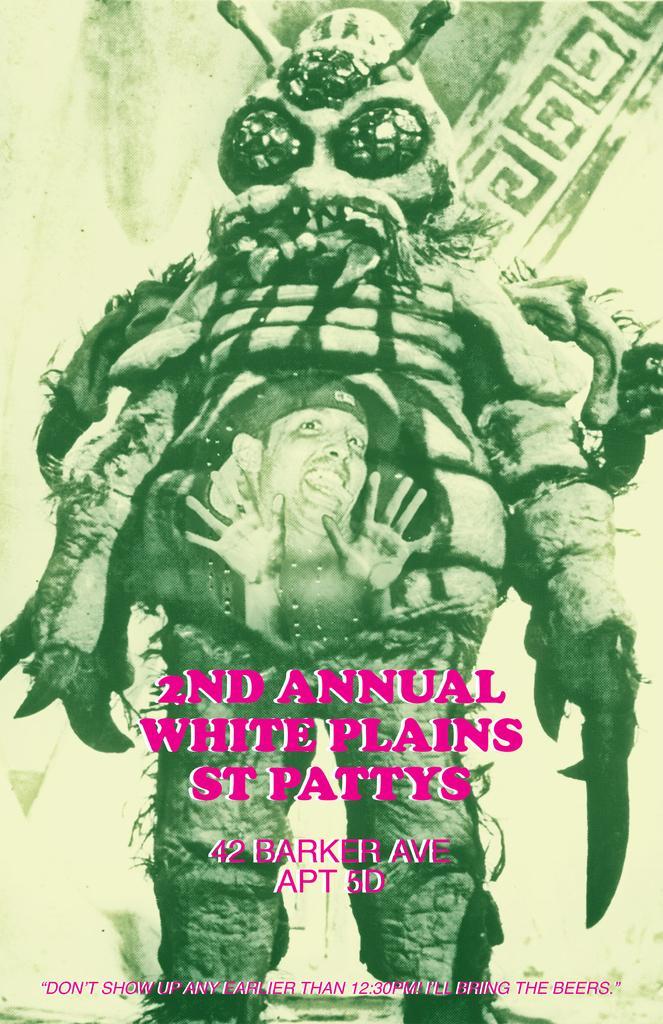Please provide a concise description of this image. This is a poster where we can see a cartoon, a person and some text. 